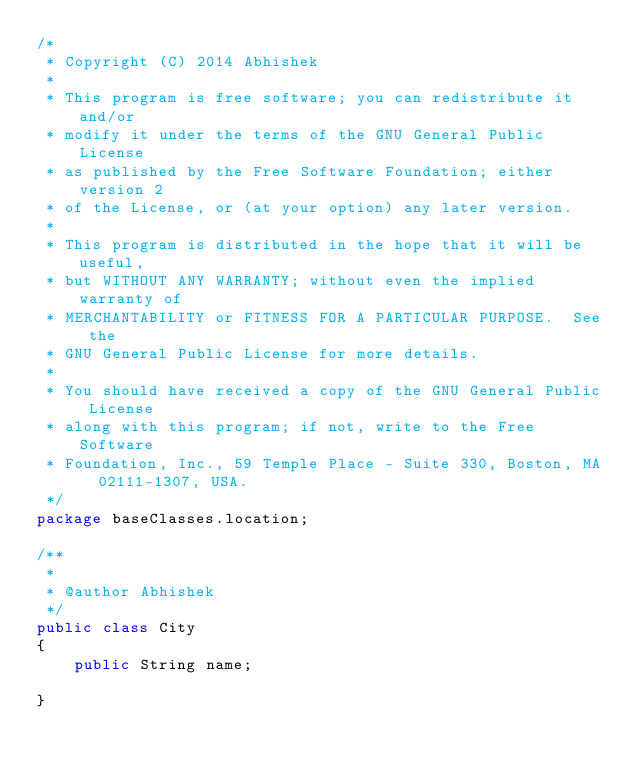Convert code to text. <code><loc_0><loc_0><loc_500><loc_500><_Java_>/*
 * Copyright (C) 2014 Abhishek
 *
 * This program is free software; you can redistribute it and/or
 * modify it under the terms of the GNU General Public License
 * as published by the Free Software Foundation; either version 2
 * of the License, or (at your option) any later version.
 *
 * This program is distributed in the hope that it will be useful,
 * but WITHOUT ANY WARRANTY; without even the implied warranty of
 * MERCHANTABILITY or FITNESS FOR A PARTICULAR PURPOSE.  See the
 * GNU General Public License for more details.
 *
 * You should have received a copy of the GNU General Public License
 * along with this program; if not, write to the Free Software
 * Foundation, Inc., 59 Temple Place - Suite 330, Boston, MA  02111-1307, USA.
 */
package baseClasses.location;

/**
 *
 * @author Abhishek
 */
public class City
{
    public String name;
    
}
</code> 